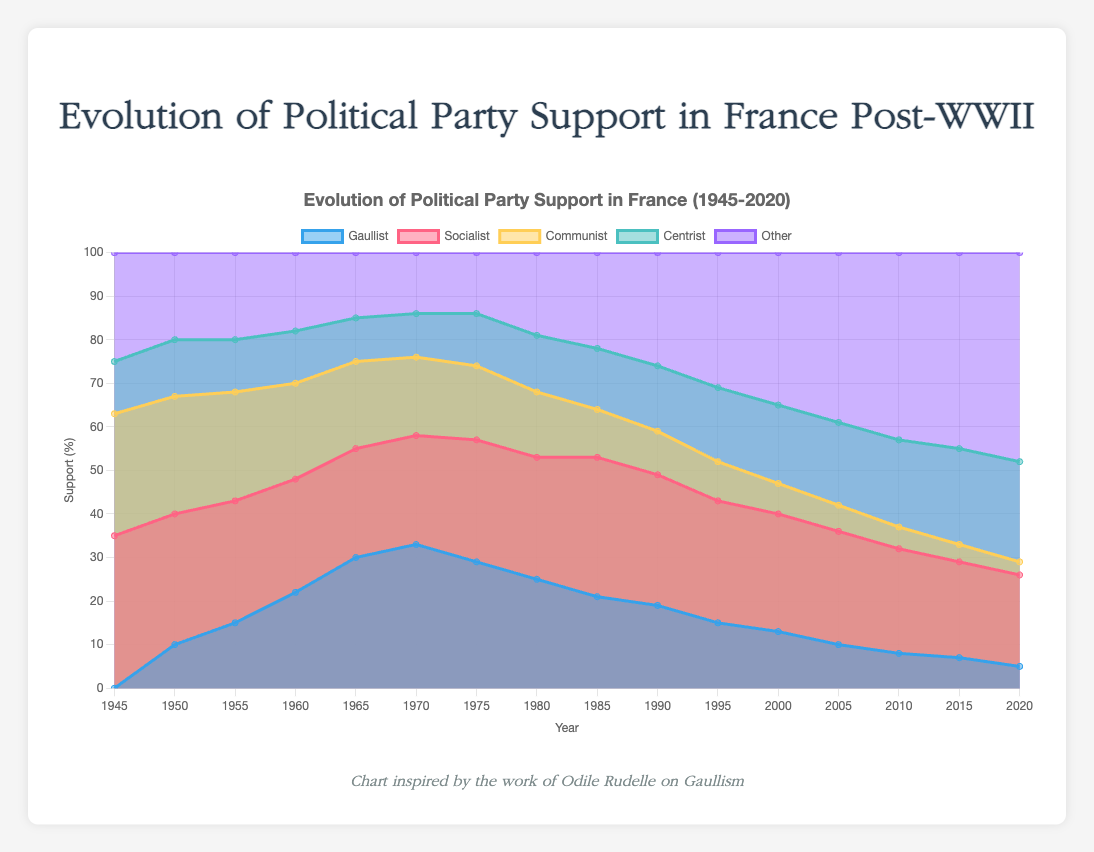What is the title of the chart? The chart has a title that describes the content depicted in the visual representation. The title is typically placed at the top of the chart.
Answer: Evolution of Political Party Support in France Post-WWII Which political party had the highest support in 1945? Look at the data line for 1945 and observe which party has the highest value.
Answer: Socialist How did the support for the Gaullist party change from 1945 to 1960? Compare the data points for the Gaullist party in the years 1945 and 1960. The support increased from 0% in 1945 to 22% in 1960.
Answer: Increased What is the general trend of the Communist party support between 1945 and 2020? Observe the line representing the Communist party from 1945 to 2020. The trend shows a general decrease in support over time.
Answer: Decreased Which party had the smallest percentage of support in 2020? Look at the data for each party in the year 2020 and identify the one with the lowest value.
Answer: Communist By how much did the support for the Socialist party change between 1985 and 2020? Subtract the percentage of Socialist party support in 2020 from that in 1985: 21% - 32% = -11%.
Answer: Decreased by 11% In what year did the Gaullist party reach its peak support? Find the highest value on the line representing the Gaullist party and check the corresponding year.
Answer: 1970 Compare the support for the Centrist party with the Gaullist party in 1975. Which one had more support? Look at the data points for both the Centrist and Gaullist parties in 1975 and compare their values.
Answer: Gaullist What is the trend of the "Other" category over the years? Observe the line representing the "Other" category from 1945 to 2020. The trend shows an increase in support over time.
Answer: Increased In which decade did the support for the Socialist party maintain its highest level? Identify the decade where the Socialist party's support values are the highest overall. The 1980s consistently show high values, peaking in 1985.
Answer: 1980s 